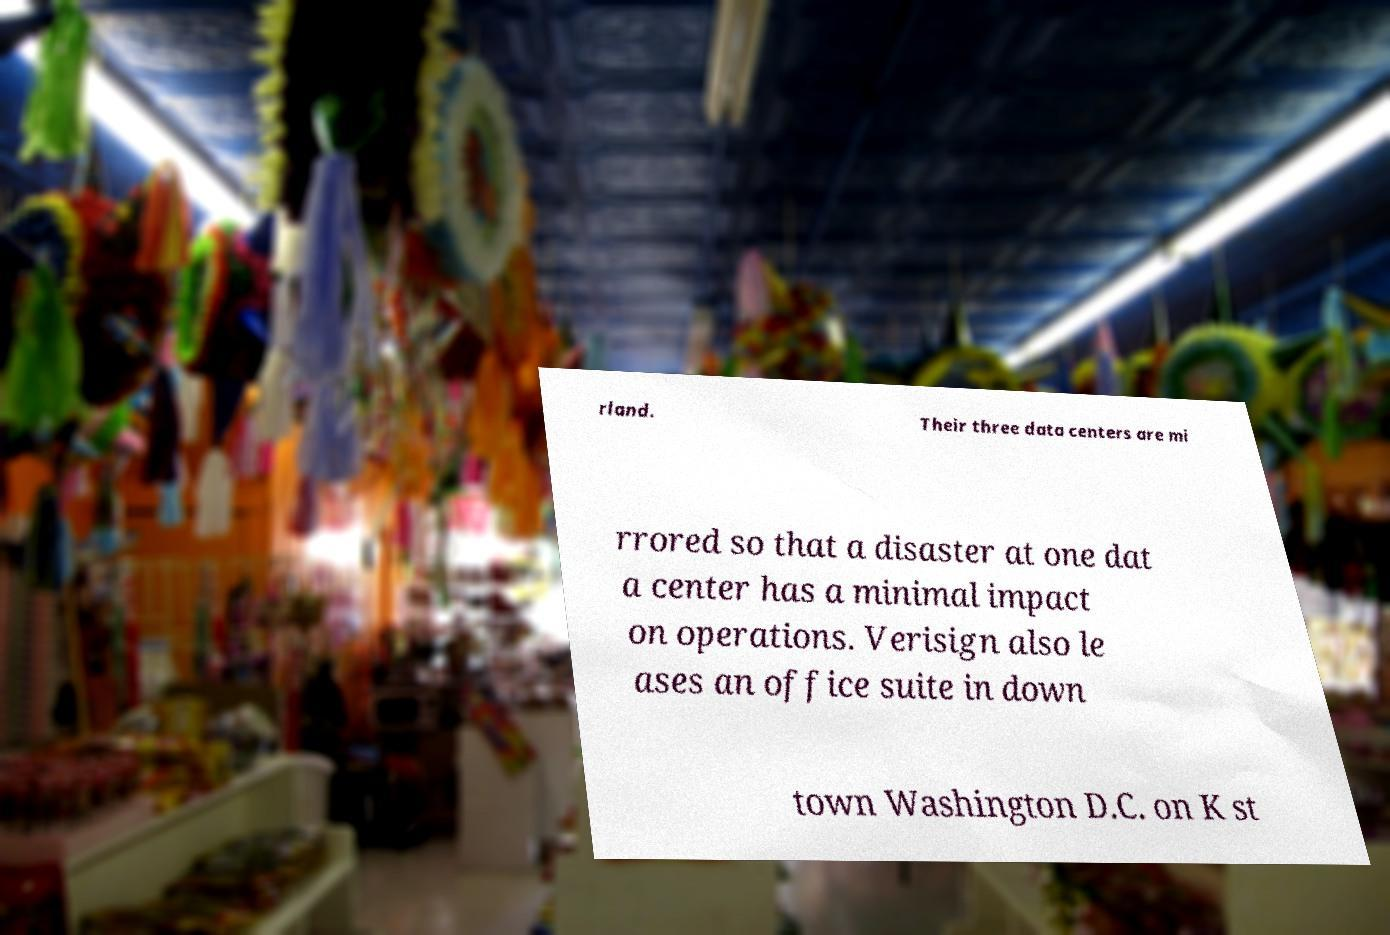There's text embedded in this image that I need extracted. Can you transcribe it verbatim? rland. Their three data centers are mi rrored so that a disaster at one dat a center has a minimal impact on operations. Verisign also le ases an office suite in down town Washington D.C. on K st 